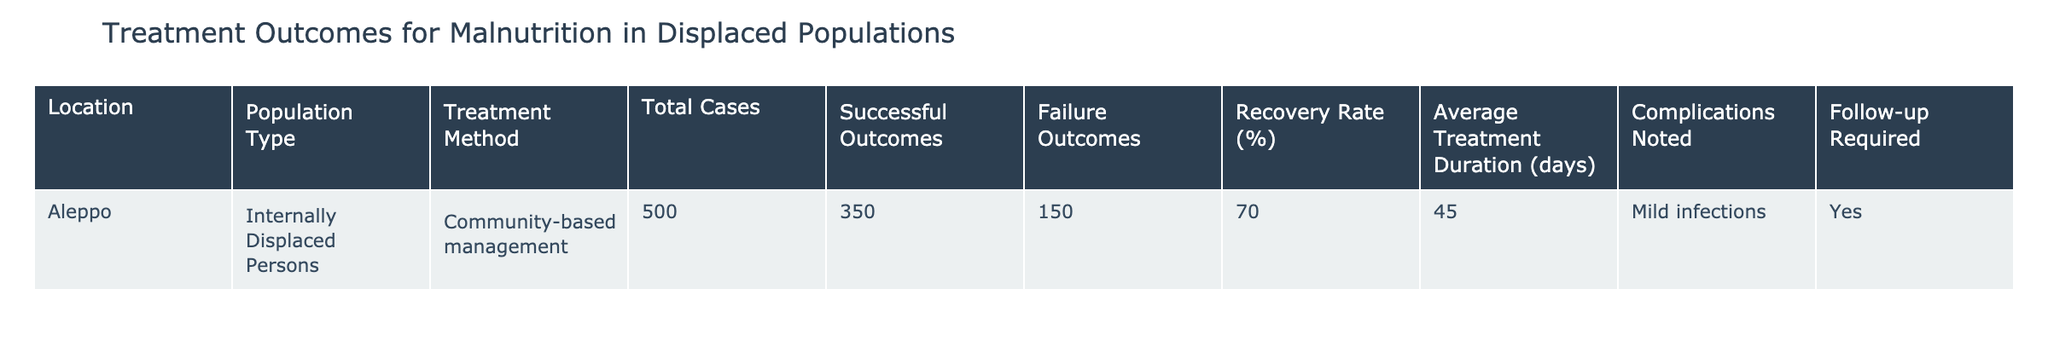What is the total number of cases treated for malnutrition in Aleppo? The table shows that the total number of cases treated for malnutrition in Aleppo is listed in the Total Cases column, which states 500.
Answer: 500 What was the recovery rate for malnutrition treatment in Aleppo? The recovery rate is found in the Recovery Rate (%) column, where it indicates a rate of 70%.
Answer: 70% How many unsuccessful treatment outcomes were recorded in Aleppo? The Failure Outcomes column displays the number of unsuccessful treatment outcomes, which is 150.
Answer: 150 Was there a follow-up required for the treatment in Aleppo? The Follow-up Required column indicates "Yes" for Aleppo, meaning a follow-up was necessary.
Answer: Yes What is the average treatment duration in days for malnutrition in Aleppo? The Average Treatment Duration (days) column shows the average treatment duration as 45 days.
Answer: 45 What percentage of cases resulted in successful outcomes in Aleppo? The Successful Outcomes column indicates 350 successful cases out of 500 total cases, leading to a calculation of (350/500) * 100 = 70%.
Answer: 70% If we combine the successful and failure outcomes, how many total outcomes were there? By adding the Successful Outcomes (350) and Failure Outcomes (150), the total outcomes are calculated as 350 + 150 = 500.
Answer: 500 What are the complications noted during treatment in Aleppo? The Complications Noted column lists "Mild infections" as the noted complication during treatment.
Answer: Mild infections Is the recovery rate higher than the average treatment duration in days? The recovery rate is 70%, while the average treatment duration is 45 days; since comparing percentages to days doesn't directly yield a conventional comparison, the recovery rate is indeed a higher metric regarding treatment success follow-up.
Answer: Yes What is the difference between total cases and successful outcomes in Aleppo? To find the difference, subtract Successful Outcomes (350) from Total Cases (500), which gives 500 - 350 = 150.
Answer: 150 